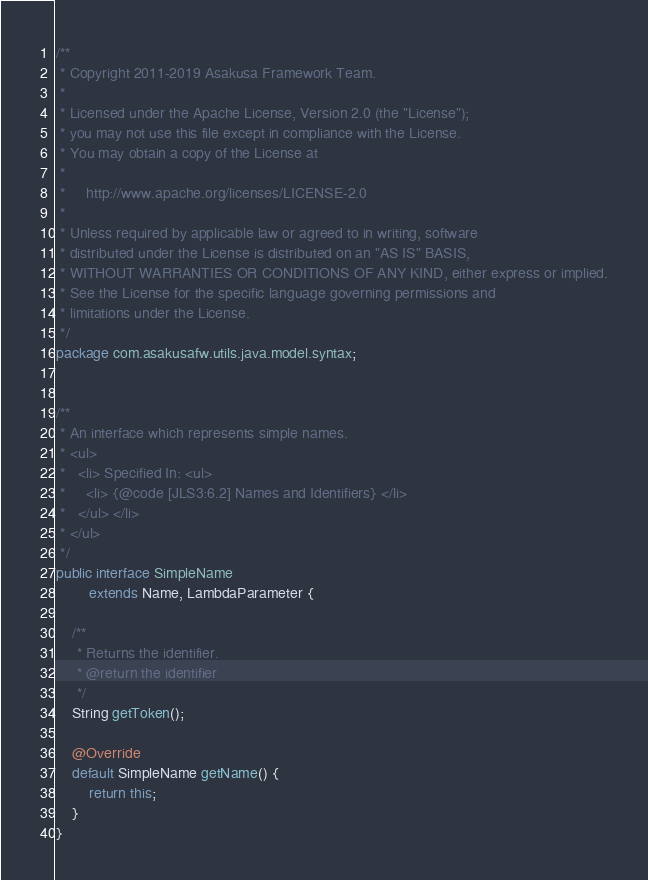<code> <loc_0><loc_0><loc_500><loc_500><_Java_>/**
 * Copyright 2011-2019 Asakusa Framework Team.
 *
 * Licensed under the Apache License, Version 2.0 (the "License");
 * you may not use this file except in compliance with the License.
 * You may obtain a copy of the License at
 *
 *     http://www.apache.org/licenses/LICENSE-2.0
 *
 * Unless required by applicable law or agreed to in writing, software
 * distributed under the License is distributed on an "AS IS" BASIS,
 * WITHOUT WARRANTIES OR CONDITIONS OF ANY KIND, either express or implied.
 * See the License for the specific language governing permissions and
 * limitations under the License.
 */
package com.asakusafw.utils.java.model.syntax;


/**
 * An interface which represents simple names.
 * <ul>
 *   <li> Specified In: <ul>
 *     <li> {@code [JLS3:6.2] Names and Identifiers} </li>
 *   </ul> </li>
 * </ul>
 */
public interface SimpleName
        extends Name, LambdaParameter {

    /**
     * Returns the identifier.
     * @return the identifier
     */
    String getToken();

    @Override
    default SimpleName getName() {
        return this;
    }
}
</code> 